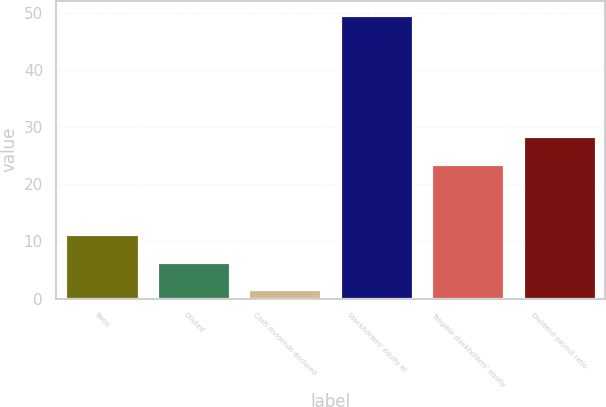Convert chart to OTSL. <chart><loc_0><loc_0><loc_500><loc_500><bar_chart><fcel>Basic<fcel>Diluted<fcel>Cash dividends declared<fcel>Stockholders' equity at<fcel>Tangible stockholders' equity<fcel>Dividend payout ratio<nl><fcel>11.22<fcel>6.41<fcel>1.6<fcel>49.68<fcel>23.62<fcel>28.43<nl></chart> 